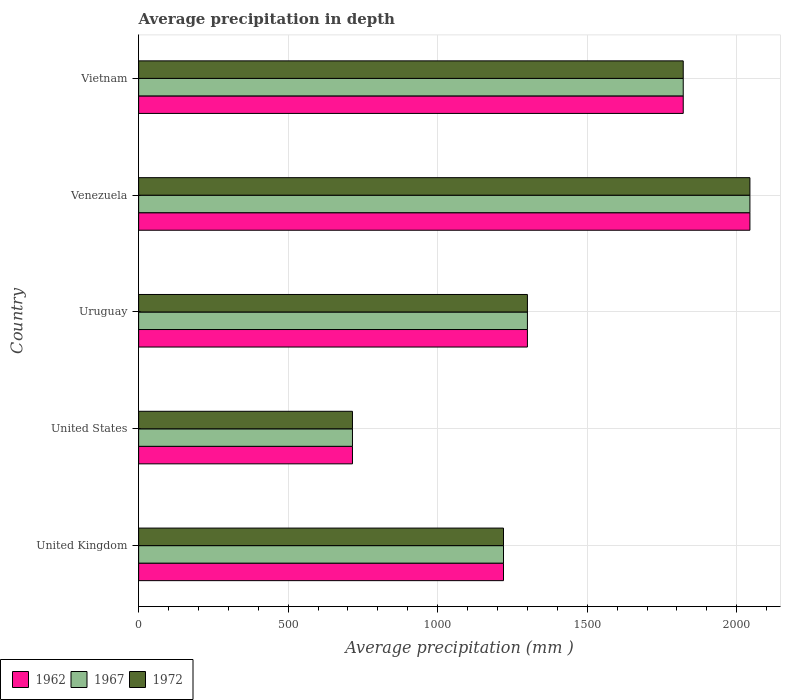How many different coloured bars are there?
Your response must be concise. 3. How many groups of bars are there?
Give a very brief answer. 5. Are the number of bars per tick equal to the number of legend labels?
Provide a succinct answer. Yes. How many bars are there on the 3rd tick from the top?
Your answer should be compact. 3. How many bars are there on the 2nd tick from the bottom?
Your answer should be compact. 3. In how many cases, is the number of bars for a given country not equal to the number of legend labels?
Keep it short and to the point. 0. What is the average precipitation in 1967 in Venezuela?
Offer a terse response. 2044. Across all countries, what is the maximum average precipitation in 1967?
Give a very brief answer. 2044. Across all countries, what is the minimum average precipitation in 1962?
Your answer should be compact. 715. In which country was the average precipitation in 1962 maximum?
Your answer should be compact. Venezuela. What is the total average precipitation in 1962 in the graph?
Provide a short and direct response. 7100. What is the difference between the average precipitation in 1967 in United States and that in Vietnam?
Make the answer very short. -1106. What is the difference between the average precipitation in 1967 in Vietnam and the average precipitation in 1962 in Venezuela?
Your answer should be compact. -223. What is the average average precipitation in 1972 per country?
Provide a succinct answer. 1420. What is the difference between the average precipitation in 1967 and average precipitation in 1972 in United States?
Make the answer very short. 0. What is the ratio of the average precipitation in 1967 in United States to that in Venezuela?
Provide a short and direct response. 0.35. Is the average precipitation in 1967 in United States less than that in Vietnam?
Keep it short and to the point. Yes. Is the difference between the average precipitation in 1967 in United Kingdom and Uruguay greater than the difference between the average precipitation in 1972 in United Kingdom and Uruguay?
Provide a succinct answer. No. What is the difference between the highest and the second highest average precipitation in 1962?
Your answer should be very brief. 223. What is the difference between the highest and the lowest average precipitation in 1972?
Make the answer very short. 1329. In how many countries, is the average precipitation in 1967 greater than the average average precipitation in 1967 taken over all countries?
Ensure brevity in your answer.  2. What does the 2nd bar from the top in Venezuela represents?
Your answer should be compact. 1967. Are all the bars in the graph horizontal?
Provide a succinct answer. Yes. What is the difference between two consecutive major ticks on the X-axis?
Make the answer very short. 500. How many legend labels are there?
Ensure brevity in your answer.  3. What is the title of the graph?
Offer a terse response. Average precipitation in depth. Does "1990" appear as one of the legend labels in the graph?
Provide a succinct answer. No. What is the label or title of the X-axis?
Offer a terse response. Average precipitation (mm ). What is the label or title of the Y-axis?
Offer a terse response. Country. What is the Average precipitation (mm ) in 1962 in United Kingdom?
Provide a succinct answer. 1220. What is the Average precipitation (mm ) of 1967 in United Kingdom?
Your answer should be compact. 1220. What is the Average precipitation (mm ) of 1972 in United Kingdom?
Keep it short and to the point. 1220. What is the Average precipitation (mm ) of 1962 in United States?
Your answer should be very brief. 715. What is the Average precipitation (mm ) of 1967 in United States?
Your answer should be very brief. 715. What is the Average precipitation (mm ) of 1972 in United States?
Your response must be concise. 715. What is the Average precipitation (mm ) of 1962 in Uruguay?
Your response must be concise. 1300. What is the Average precipitation (mm ) of 1967 in Uruguay?
Provide a succinct answer. 1300. What is the Average precipitation (mm ) in 1972 in Uruguay?
Your answer should be very brief. 1300. What is the Average precipitation (mm ) of 1962 in Venezuela?
Provide a short and direct response. 2044. What is the Average precipitation (mm ) in 1967 in Venezuela?
Keep it short and to the point. 2044. What is the Average precipitation (mm ) in 1972 in Venezuela?
Offer a very short reply. 2044. What is the Average precipitation (mm ) in 1962 in Vietnam?
Offer a terse response. 1821. What is the Average precipitation (mm ) of 1967 in Vietnam?
Offer a terse response. 1821. What is the Average precipitation (mm ) in 1972 in Vietnam?
Ensure brevity in your answer.  1821. Across all countries, what is the maximum Average precipitation (mm ) of 1962?
Give a very brief answer. 2044. Across all countries, what is the maximum Average precipitation (mm ) of 1967?
Offer a very short reply. 2044. Across all countries, what is the maximum Average precipitation (mm ) in 1972?
Your response must be concise. 2044. Across all countries, what is the minimum Average precipitation (mm ) of 1962?
Give a very brief answer. 715. Across all countries, what is the minimum Average precipitation (mm ) of 1967?
Make the answer very short. 715. Across all countries, what is the minimum Average precipitation (mm ) in 1972?
Your answer should be compact. 715. What is the total Average precipitation (mm ) of 1962 in the graph?
Your answer should be very brief. 7100. What is the total Average precipitation (mm ) of 1967 in the graph?
Give a very brief answer. 7100. What is the total Average precipitation (mm ) of 1972 in the graph?
Your response must be concise. 7100. What is the difference between the Average precipitation (mm ) in 1962 in United Kingdom and that in United States?
Provide a short and direct response. 505. What is the difference between the Average precipitation (mm ) of 1967 in United Kingdom and that in United States?
Offer a very short reply. 505. What is the difference between the Average precipitation (mm ) in 1972 in United Kingdom and that in United States?
Your answer should be compact. 505. What is the difference between the Average precipitation (mm ) in 1962 in United Kingdom and that in Uruguay?
Your answer should be very brief. -80. What is the difference between the Average precipitation (mm ) of 1967 in United Kingdom and that in Uruguay?
Keep it short and to the point. -80. What is the difference between the Average precipitation (mm ) in 1972 in United Kingdom and that in Uruguay?
Offer a terse response. -80. What is the difference between the Average precipitation (mm ) in 1962 in United Kingdom and that in Venezuela?
Provide a short and direct response. -824. What is the difference between the Average precipitation (mm ) of 1967 in United Kingdom and that in Venezuela?
Your answer should be very brief. -824. What is the difference between the Average precipitation (mm ) of 1972 in United Kingdom and that in Venezuela?
Provide a short and direct response. -824. What is the difference between the Average precipitation (mm ) of 1962 in United Kingdom and that in Vietnam?
Your response must be concise. -601. What is the difference between the Average precipitation (mm ) in 1967 in United Kingdom and that in Vietnam?
Offer a terse response. -601. What is the difference between the Average precipitation (mm ) of 1972 in United Kingdom and that in Vietnam?
Keep it short and to the point. -601. What is the difference between the Average precipitation (mm ) of 1962 in United States and that in Uruguay?
Offer a terse response. -585. What is the difference between the Average precipitation (mm ) of 1967 in United States and that in Uruguay?
Keep it short and to the point. -585. What is the difference between the Average precipitation (mm ) of 1972 in United States and that in Uruguay?
Give a very brief answer. -585. What is the difference between the Average precipitation (mm ) in 1962 in United States and that in Venezuela?
Offer a very short reply. -1329. What is the difference between the Average precipitation (mm ) of 1967 in United States and that in Venezuela?
Give a very brief answer. -1329. What is the difference between the Average precipitation (mm ) of 1972 in United States and that in Venezuela?
Provide a short and direct response. -1329. What is the difference between the Average precipitation (mm ) of 1962 in United States and that in Vietnam?
Make the answer very short. -1106. What is the difference between the Average precipitation (mm ) of 1967 in United States and that in Vietnam?
Provide a succinct answer. -1106. What is the difference between the Average precipitation (mm ) in 1972 in United States and that in Vietnam?
Give a very brief answer. -1106. What is the difference between the Average precipitation (mm ) in 1962 in Uruguay and that in Venezuela?
Your answer should be compact. -744. What is the difference between the Average precipitation (mm ) of 1967 in Uruguay and that in Venezuela?
Offer a terse response. -744. What is the difference between the Average precipitation (mm ) in 1972 in Uruguay and that in Venezuela?
Your answer should be very brief. -744. What is the difference between the Average precipitation (mm ) of 1962 in Uruguay and that in Vietnam?
Provide a short and direct response. -521. What is the difference between the Average precipitation (mm ) of 1967 in Uruguay and that in Vietnam?
Provide a succinct answer. -521. What is the difference between the Average precipitation (mm ) in 1972 in Uruguay and that in Vietnam?
Your response must be concise. -521. What is the difference between the Average precipitation (mm ) in 1962 in Venezuela and that in Vietnam?
Your answer should be compact. 223. What is the difference between the Average precipitation (mm ) in 1967 in Venezuela and that in Vietnam?
Your answer should be compact. 223. What is the difference between the Average precipitation (mm ) in 1972 in Venezuela and that in Vietnam?
Offer a terse response. 223. What is the difference between the Average precipitation (mm ) of 1962 in United Kingdom and the Average precipitation (mm ) of 1967 in United States?
Your response must be concise. 505. What is the difference between the Average precipitation (mm ) of 1962 in United Kingdom and the Average precipitation (mm ) of 1972 in United States?
Give a very brief answer. 505. What is the difference between the Average precipitation (mm ) of 1967 in United Kingdom and the Average precipitation (mm ) of 1972 in United States?
Make the answer very short. 505. What is the difference between the Average precipitation (mm ) of 1962 in United Kingdom and the Average precipitation (mm ) of 1967 in Uruguay?
Your answer should be compact. -80. What is the difference between the Average precipitation (mm ) in 1962 in United Kingdom and the Average precipitation (mm ) in 1972 in Uruguay?
Keep it short and to the point. -80. What is the difference between the Average precipitation (mm ) in 1967 in United Kingdom and the Average precipitation (mm ) in 1972 in Uruguay?
Ensure brevity in your answer.  -80. What is the difference between the Average precipitation (mm ) of 1962 in United Kingdom and the Average precipitation (mm ) of 1967 in Venezuela?
Offer a terse response. -824. What is the difference between the Average precipitation (mm ) of 1962 in United Kingdom and the Average precipitation (mm ) of 1972 in Venezuela?
Provide a succinct answer. -824. What is the difference between the Average precipitation (mm ) of 1967 in United Kingdom and the Average precipitation (mm ) of 1972 in Venezuela?
Keep it short and to the point. -824. What is the difference between the Average precipitation (mm ) in 1962 in United Kingdom and the Average precipitation (mm ) in 1967 in Vietnam?
Provide a short and direct response. -601. What is the difference between the Average precipitation (mm ) in 1962 in United Kingdom and the Average precipitation (mm ) in 1972 in Vietnam?
Provide a succinct answer. -601. What is the difference between the Average precipitation (mm ) of 1967 in United Kingdom and the Average precipitation (mm ) of 1972 in Vietnam?
Give a very brief answer. -601. What is the difference between the Average precipitation (mm ) of 1962 in United States and the Average precipitation (mm ) of 1967 in Uruguay?
Provide a succinct answer. -585. What is the difference between the Average precipitation (mm ) of 1962 in United States and the Average precipitation (mm ) of 1972 in Uruguay?
Give a very brief answer. -585. What is the difference between the Average precipitation (mm ) in 1967 in United States and the Average precipitation (mm ) in 1972 in Uruguay?
Give a very brief answer. -585. What is the difference between the Average precipitation (mm ) in 1962 in United States and the Average precipitation (mm ) in 1967 in Venezuela?
Give a very brief answer. -1329. What is the difference between the Average precipitation (mm ) in 1962 in United States and the Average precipitation (mm ) in 1972 in Venezuela?
Your response must be concise. -1329. What is the difference between the Average precipitation (mm ) of 1967 in United States and the Average precipitation (mm ) of 1972 in Venezuela?
Your answer should be very brief. -1329. What is the difference between the Average precipitation (mm ) in 1962 in United States and the Average precipitation (mm ) in 1967 in Vietnam?
Your answer should be very brief. -1106. What is the difference between the Average precipitation (mm ) in 1962 in United States and the Average precipitation (mm ) in 1972 in Vietnam?
Provide a succinct answer. -1106. What is the difference between the Average precipitation (mm ) in 1967 in United States and the Average precipitation (mm ) in 1972 in Vietnam?
Offer a very short reply. -1106. What is the difference between the Average precipitation (mm ) in 1962 in Uruguay and the Average precipitation (mm ) in 1967 in Venezuela?
Provide a succinct answer. -744. What is the difference between the Average precipitation (mm ) of 1962 in Uruguay and the Average precipitation (mm ) of 1972 in Venezuela?
Your answer should be compact. -744. What is the difference between the Average precipitation (mm ) in 1967 in Uruguay and the Average precipitation (mm ) in 1972 in Venezuela?
Provide a succinct answer. -744. What is the difference between the Average precipitation (mm ) in 1962 in Uruguay and the Average precipitation (mm ) in 1967 in Vietnam?
Make the answer very short. -521. What is the difference between the Average precipitation (mm ) in 1962 in Uruguay and the Average precipitation (mm ) in 1972 in Vietnam?
Give a very brief answer. -521. What is the difference between the Average precipitation (mm ) of 1967 in Uruguay and the Average precipitation (mm ) of 1972 in Vietnam?
Keep it short and to the point. -521. What is the difference between the Average precipitation (mm ) in 1962 in Venezuela and the Average precipitation (mm ) in 1967 in Vietnam?
Ensure brevity in your answer.  223. What is the difference between the Average precipitation (mm ) of 1962 in Venezuela and the Average precipitation (mm ) of 1972 in Vietnam?
Your response must be concise. 223. What is the difference between the Average precipitation (mm ) of 1967 in Venezuela and the Average precipitation (mm ) of 1972 in Vietnam?
Provide a short and direct response. 223. What is the average Average precipitation (mm ) in 1962 per country?
Make the answer very short. 1420. What is the average Average precipitation (mm ) of 1967 per country?
Your answer should be very brief. 1420. What is the average Average precipitation (mm ) of 1972 per country?
Your answer should be compact. 1420. What is the difference between the Average precipitation (mm ) of 1962 and Average precipitation (mm ) of 1967 in United Kingdom?
Give a very brief answer. 0. What is the difference between the Average precipitation (mm ) in 1962 and Average precipitation (mm ) in 1972 in United Kingdom?
Offer a very short reply. 0. What is the difference between the Average precipitation (mm ) in 1962 and Average precipitation (mm ) in 1967 in United States?
Make the answer very short. 0. What is the difference between the Average precipitation (mm ) in 1962 and Average precipitation (mm ) in 1972 in United States?
Provide a short and direct response. 0. What is the difference between the Average precipitation (mm ) of 1967 and Average precipitation (mm ) of 1972 in United States?
Your response must be concise. 0. What is the difference between the Average precipitation (mm ) in 1962 and Average precipitation (mm ) in 1972 in Uruguay?
Offer a terse response. 0. What is the difference between the Average precipitation (mm ) in 1967 and Average precipitation (mm ) in 1972 in Uruguay?
Offer a very short reply. 0. What is the difference between the Average precipitation (mm ) of 1962 and Average precipitation (mm ) of 1967 in Venezuela?
Provide a succinct answer. 0. What is the difference between the Average precipitation (mm ) in 1962 and Average precipitation (mm ) in 1967 in Vietnam?
Your response must be concise. 0. What is the difference between the Average precipitation (mm ) in 1967 and Average precipitation (mm ) in 1972 in Vietnam?
Your response must be concise. 0. What is the ratio of the Average precipitation (mm ) in 1962 in United Kingdom to that in United States?
Keep it short and to the point. 1.71. What is the ratio of the Average precipitation (mm ) in 1967 in United Kingdom to that in United States?
Provide a short and direct response. 1.71. What is the ratio of the Average precipitation (mm ) of 1972 in United Kingdom to that in United States?
Your response must be concise. 1.71. What is the ratio of the Average precipitation (mm ) in 1962 in United Kingdom to that in Uruguay?
Your response must be concise. 0.94. What is the ratio of the Average precipitation (mm ) in 1967 in United Kingdom to that in Uruguay?
Ensure brevity in your answer.  0.94. What is the ratio of the Average precipitation (mm ) of 1972 in United Kingdom to that in Uruguay?
Provide a succinct answer. 0.94. What is the ratio of the Average precipitation (mm ) of 1962 in United Kingdom to that in Venezuela?
Give a very brief answer. 0.6. What is the ratio of the Average precipitation (mm ) in 1967 in United Kingdom to that in Venezuela?
Your response must be concise. 0.6. What is the ratio of the Average precipitation (mm ) of 1972 in United Kingdom to that in Venezuela?
Your response must be concise. 0.6. What is the ratio of the Average precipitation (mm ) of 1962 in United Kingdom to that in Vietnam?
Offer a terse response. 0.67. What is the ratio of the Average precipitation (mm ) of 1967 in United Kingdom to that in Vietnam?
Provide a succinct answer. 0.67. What is the ratio of the Average precipitation (mm ) of 1972 in United Kingdom to that in Vietnam?
Ensure brevity in your answer.  0.67. What is the ratio of the Average precipitation (mm ) of 1962 in United States to that in Uruguay?
Offer a very short reply. 0.55. What is the ratio of the Average precipitation (mm ) in 1967 in United States to that in Uruguay?
Provide a succinct answer. 0.55. What is the ratio of the Average precipitation (mm ) in 1972 in United States to that in Uruguay?
Your response must be concise. 0.55. What is the ratio of the Average precipitation (mm ) of 1962 in United States to that in Venezuela?
Your answer should be very brief. 0.35. What is the ratio of the Average precipitation (mm ) in 1967 in United States to that in Venezuela?
Ensure brevity in your answer.  0.35. What is the ratio of the Average precipitation (mm ) of 1972 in United States to that in Venezuela?
Keep it short and to the point. 0.35. What is the ratio of the Average precipitation (mm ) of 1962 in United States to that in Vietnam?
Your answer should be compact. 0.39. What is the ratio of the Average precipitation (mm ) of 1967 in United States to that in Vietnam?
Provide a succinct answer. 0.39. What is the ratio of the Average precipitation (mm ) of 1972 in United States to that in Vietnam?
Your answer should be compact. 0.39. What is the ratio of the Average precipitation (mm ) in 1962 in Uruguay to that in Venezuela?
Your answer should be compact. 0.64. What is the ratio of the Average precipitation (mm ) of 1967 in Uruguay to that in Venezuela?
Ensure brevity in your answer.  0.64. What is the ratio of the Average precipitation (mm ) of 1972 in Uruguay to that in Venezuela?
Give a very brief answer. 0.64. What is the ratio of the Average precipitation (mm ) in 1962 in Uruguay to that in Vietnam?
Offer a very short reply. 0.71. What is the ratio of the Average precipitation (mm ) in 1967 in Uruguay to that in Vietnam?
Provide a succinct answer. 0.71. What is the ratio of the Average precipitation (mm ) of 1972 in Uruguay to that in Vietnam?
Ensure brevity in your answer.  0.71. What is the ratio of the Average precipitation (mm ) of 1962 in Venezuela to that in Vietnam?
Your response must be concise. 1.12. What is the ratio of the Average precipitation (mm ) in 1967 in Venezuela to that in Vietnam?
Give a very brief answer. 1.12. What is the ratio of the Average precipitation (mm ) of 1972 in Venezuela to that in Vietnam?
Offer a terse response. 1.12. What is the difference between the highest and the second highest Average precipitation (mm ) in 1962?
Your answer should be very brief. 223. What is the difference between the highest and the second highest Average precipitation (mm ) in 1967?
Ensure brevity in your answer.  223. What is the difference between the highest and the second highest Average precipitation (mm ) in 1972?
Your answer should be very brief. 223. What is the difference between the highest and the lowest Average precipitation (mm ) of 1962?
Provide a succinct answer. 1329. What is the difference between the highest and the lowest Average precipitation (mm ) in 1967?
Provide a succinct answer. 1329. What is the difference between the highest and the lowest Average precipitation (mm ) of 1972?
Give a very brief answer. 1329. 